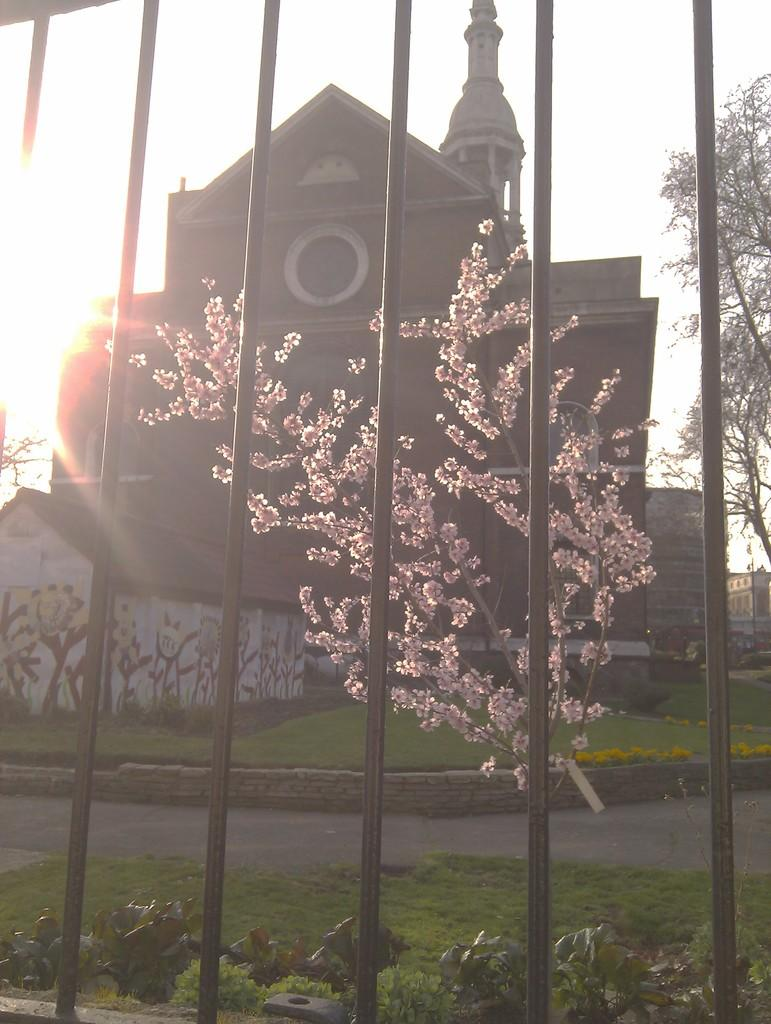What type of fencing is present in the image? There is metallic fencing in the image. What can be seen on the ground in the image? The ground is visible in the image. What type of vegetation is present in the image? There is grass, plants, and trees in the image. What type of man-made structures are present in the image? There is a house and buildings in the image. What part of the natural environment is visible in the image? The sky is visible in the image, and the sun is visible in the sky. What type of toy is being used to climb the mountain in the image? There is no mountain or toy present in the image. What selection of items can be seen on the table in the image? There is no table or selection of items present in the image. 